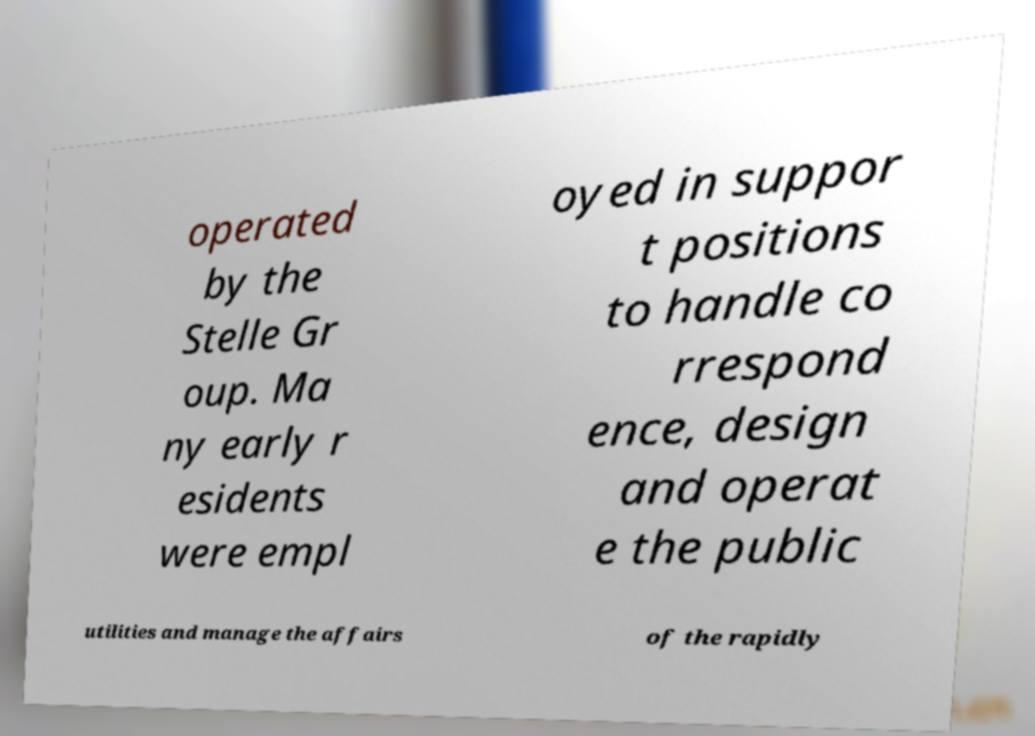I need the written content from this picture converted into text. Can you do that? operated by the Stelle Gr oup. Ma ny early r esidents were empl oyed in suppor t positions to handle co rrespond ence, design and operat e the public utilities and manage the affairs of the rapidly 